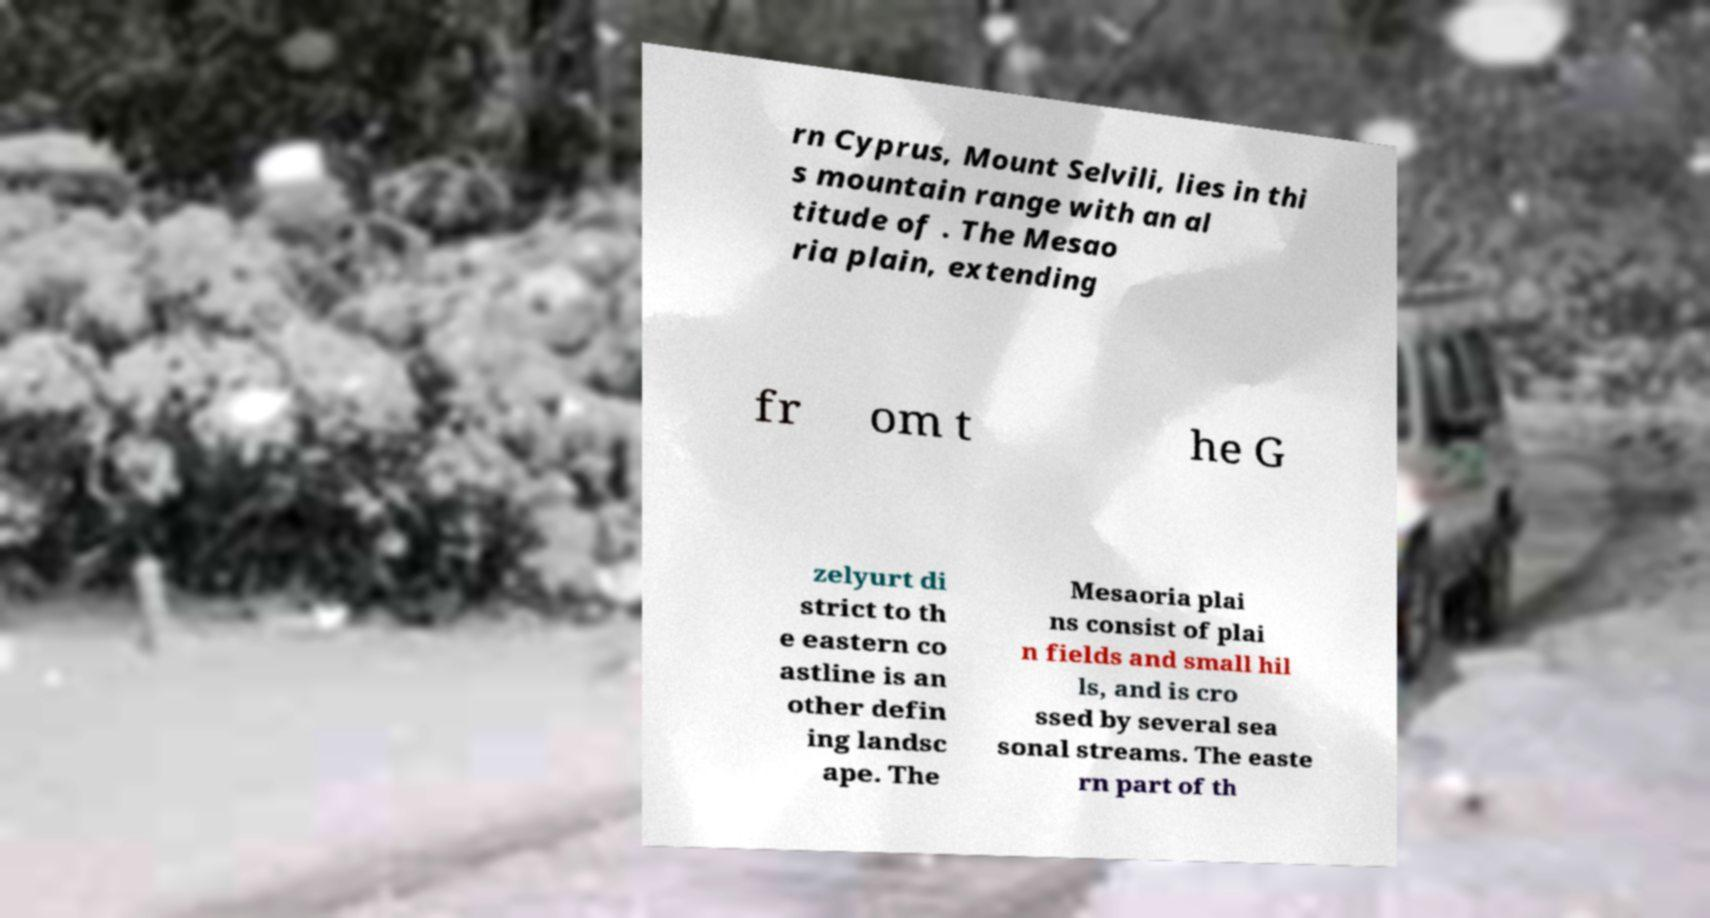Can you read and provide the text displayed in the image?This photo seems to have some interesting text. Can you extract and type it out for me? rn Cyprus, Mount Selvili, lies in thi s mountain range with an al titude of . The Mesao ria plain, extending fr om t he G zelyurt di strict to th e eastern co astline is an other defin ing landsc ape. The Mesaoria plai ns consist of plai n fields and small hil ls, and is cro ssed by several sea sonal streams. The easte rn part of th 